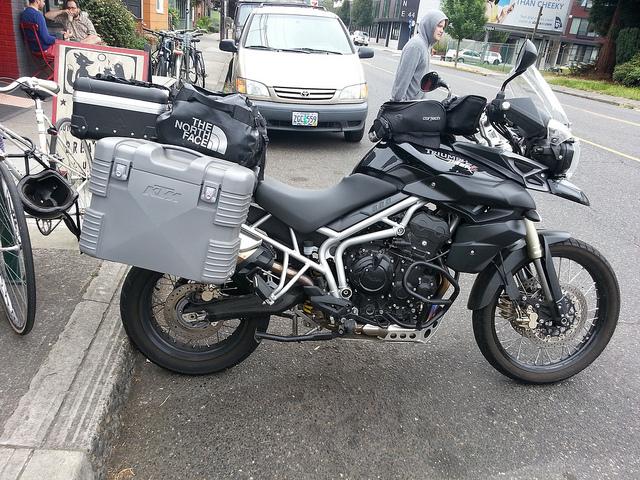How many tires does the bike have?
Answer briefly. 2. How many steps are there?
Answer briefly. 1. What says north face?
Write a very short answer. Bag. What is parked next to the motorbike?
Quick response, please. Bicycle. 